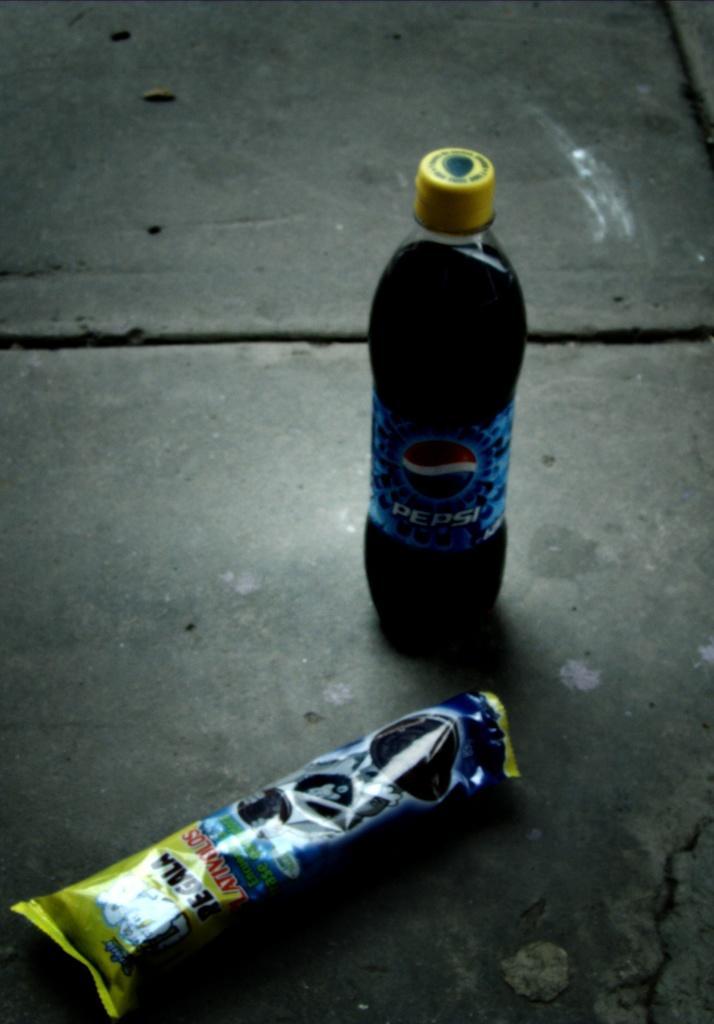Describe this image in one or two sentences. On the floor we can find the bottle of coke and chocolate wrapper. 